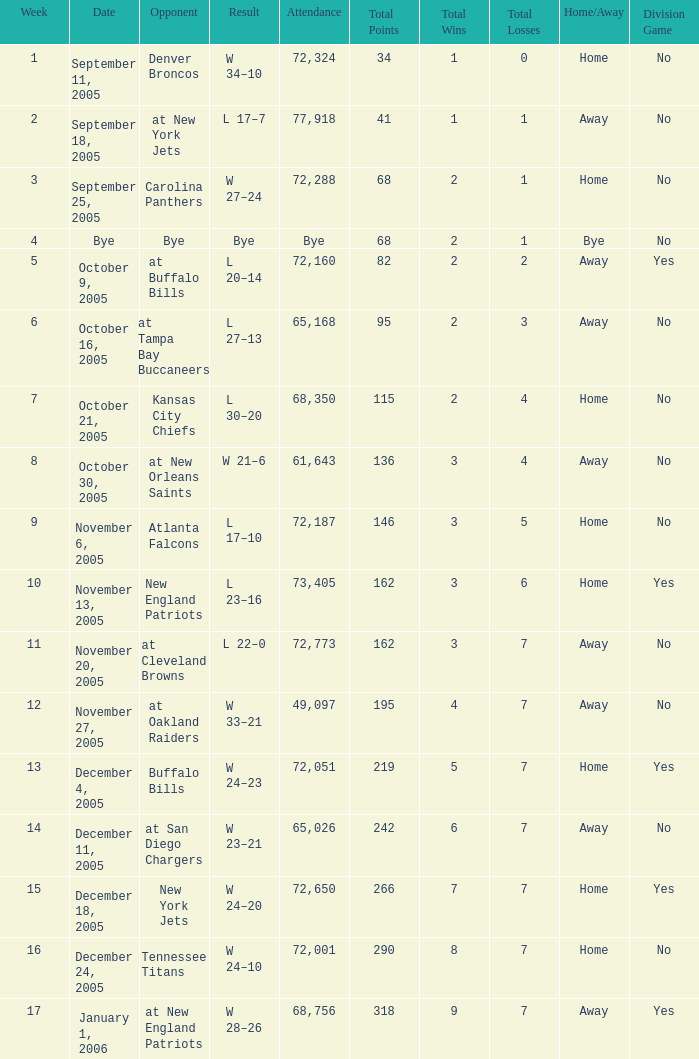In what Week was the Attendance 49,097? 12.0. 